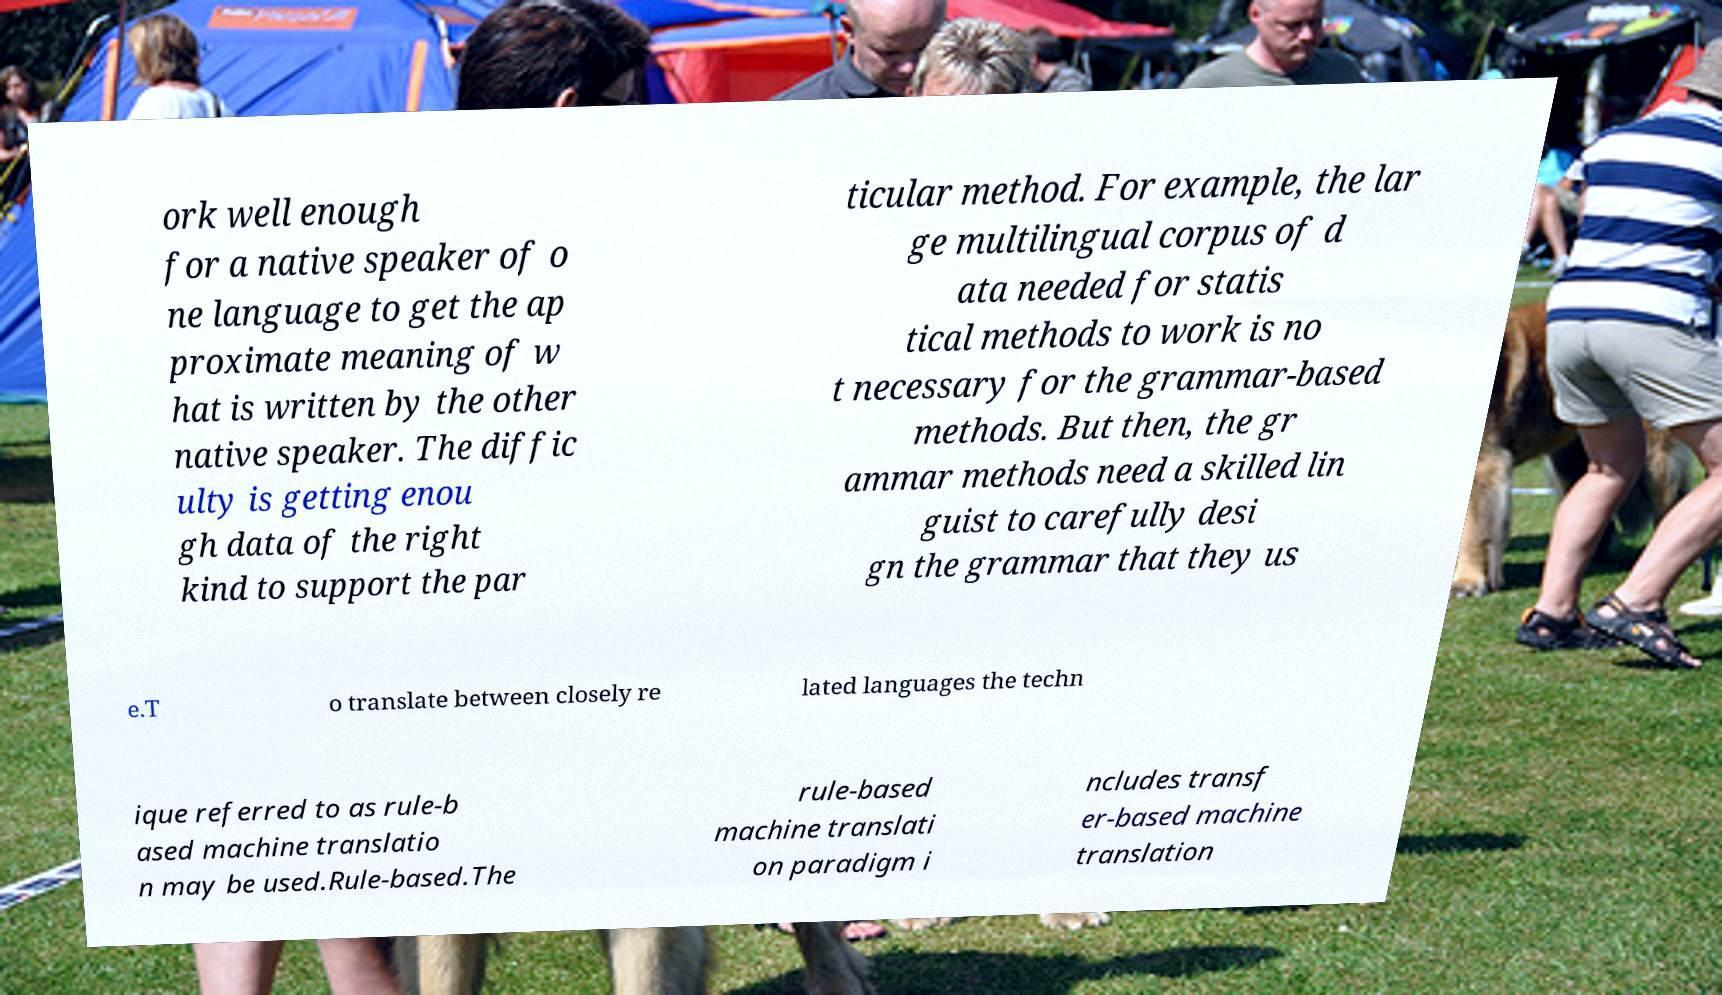Please read and relay the text visible in this image. What does it say? ork well enough for a native speaker of o ne language to get the ap proximate meaning of w hat is written by the other native speaker. The diffic ulty is getting enou gh data of the right kind to support the par ticular method. For example, the lar ge multilingual corpus of d ata needed for statis tical methods to work is no t necessary for the grammar-based methods. But then, the gr ammar methods need a skilled lin guist to carefully desi gn the grammar that they us e.T o translate between closely re lated languages the techn ique referred to as rule-b ased machine translatio n may be used.Rule-based.The rule-based machine translati on paradigm i ncludes transf er-based machine translation 